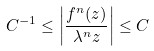<formula> <loc_0><loc_0><loc_500><loc_500>C ^ { - 1 } \leq \left | \frac { f ^ { n } ( z ) } { \lambda ^ { n } z } \right | \leq C</formula> 